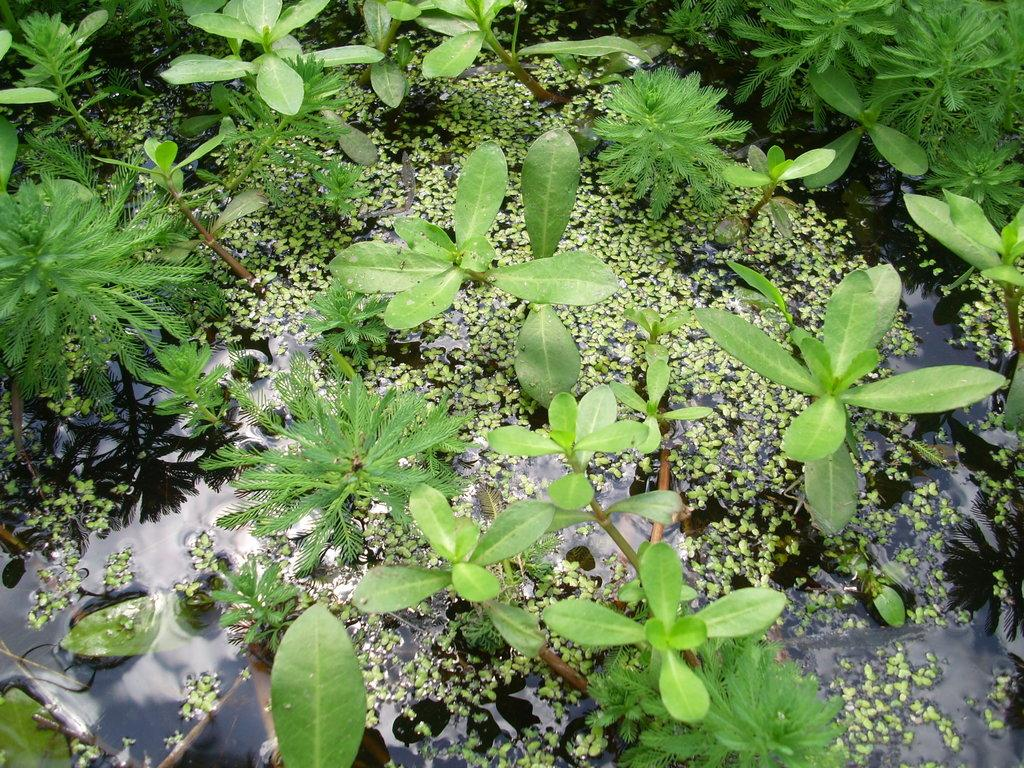What type of plants are in the image? There are small green plants in the image. Where are the plants located? The plants are in a pond. What is the environment of the plants in the image? The plants are in the water. Do the plants have any friends in the image? There is no information about friends or social interactions of the plants in the image. 